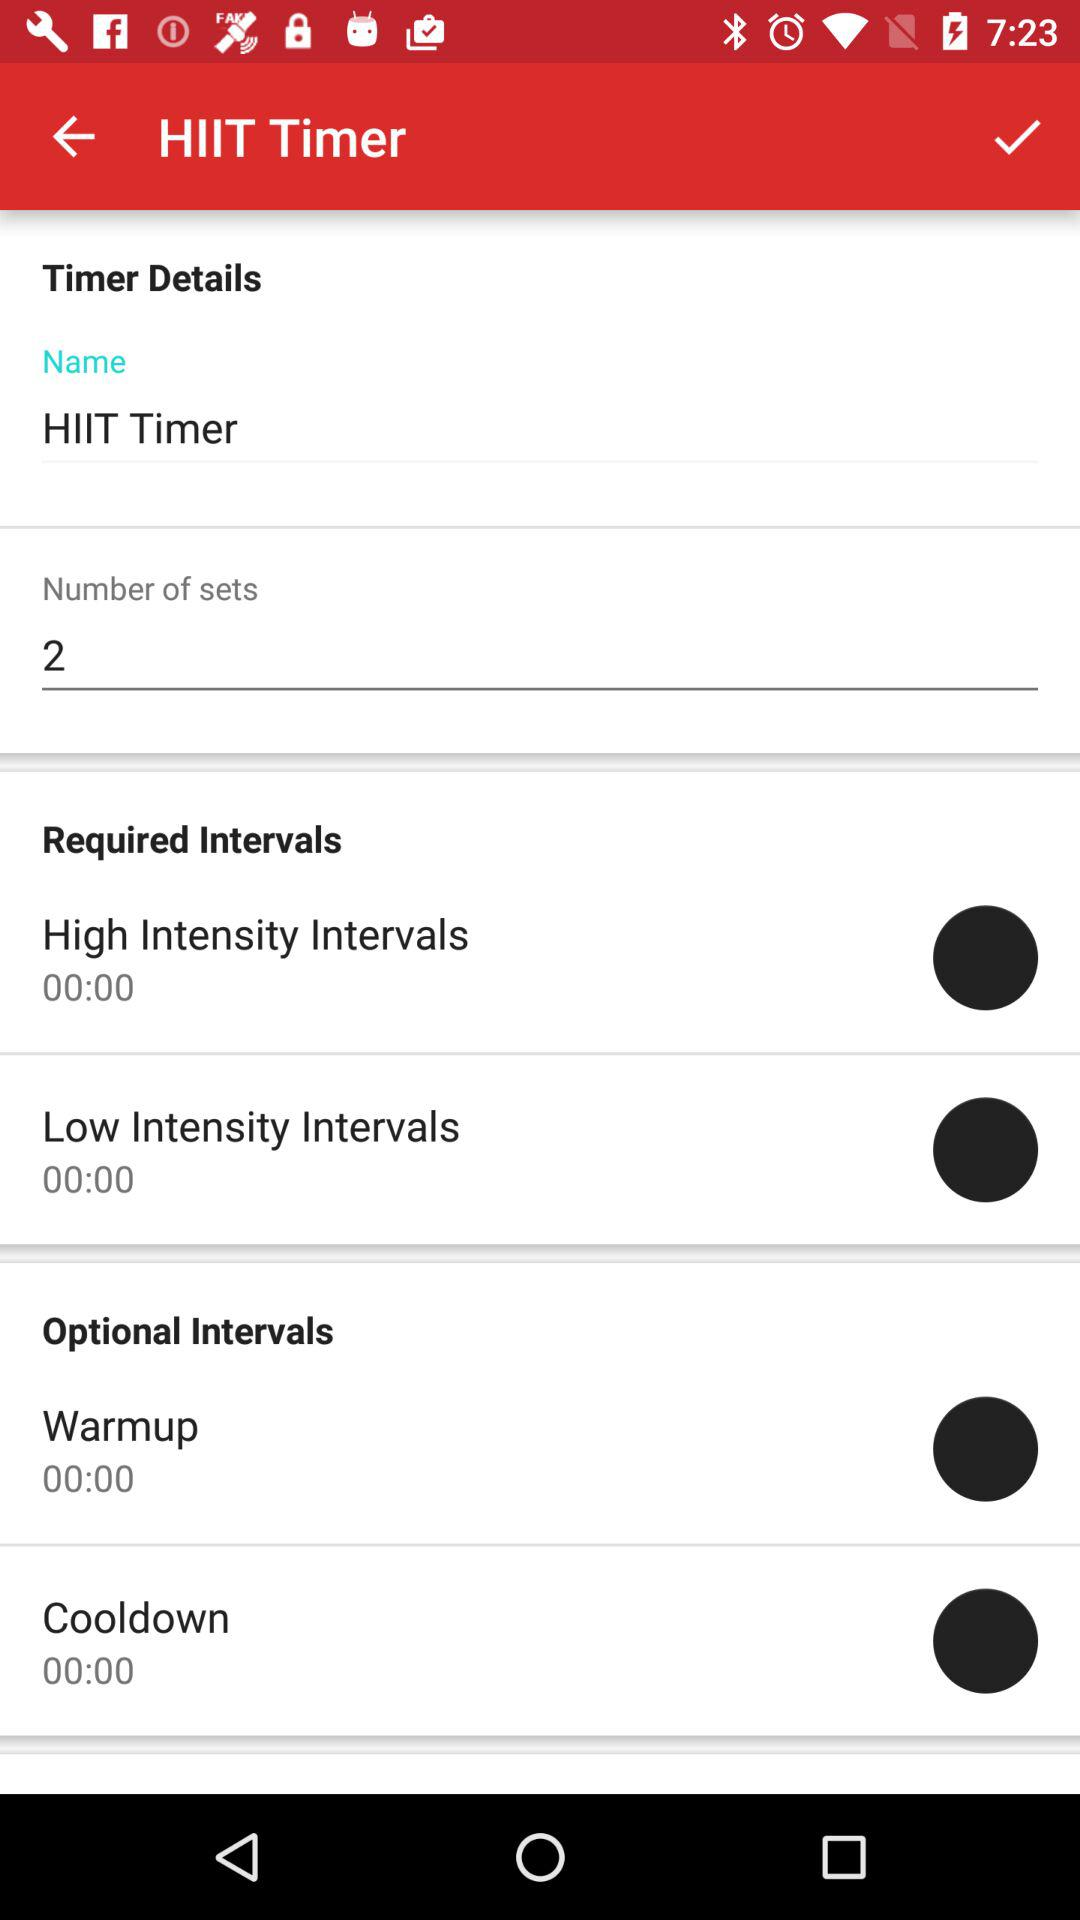How many sets does this timer have?
Answer the question using a single word or phrase. 2 